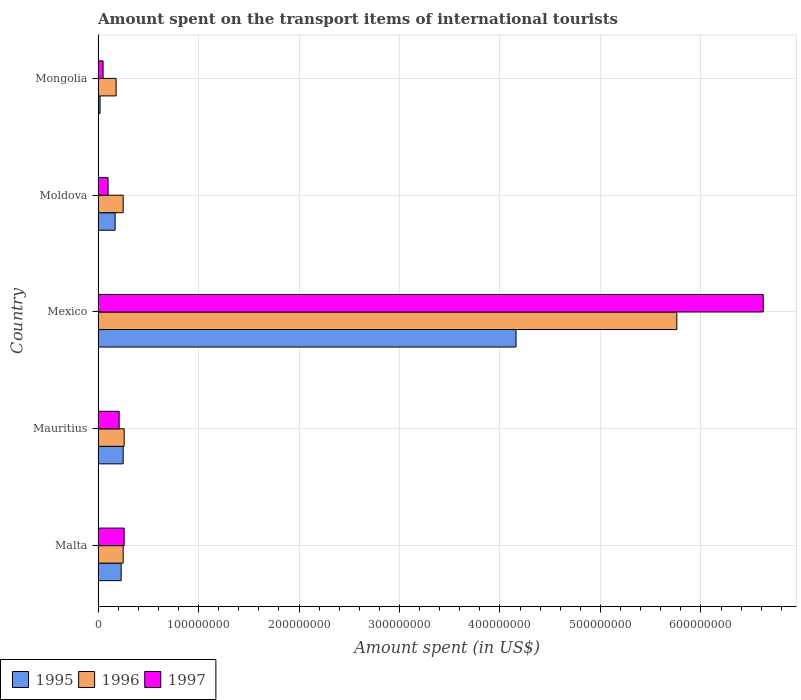Are the number of bars per tick equal to the number of legend labels?
Provide a succinct answer. Yes. How many bars are there on the 4th tick from the bottom?
Ensure brevity in your answer.  3. What is the label of the 5th group of bars from the top?
Ensure brevity in your answer.  Malta. In how many cases, is the number of bars for a given country not equal to the number of legend labels?
Give a very brief answer. 0. What is the amount spent on the transport items of international tourists in 1996 in Mexico?
Ensure brevity in your answer.  5.76e+08. Across all countries, what is the maximum amount spent on the transport items of international tourists in 1997?
Make the answer very short. 6.62e+08. Across all countries, what is the minimum amount spent on the transport items of international tourists in 1995?
Make the answer very short. 2.00e+06. In which country was the amount spent on the transport items of international tourists in 1997 maximum?
Give a very brief answer. Mexico. In which country was the amount spent on the transport items of international tourists in 1996 minimum?
Offer a terse response. Mongolia. What is the total amount spent on the transport items of international tourists in 1997 in the graph?
Your answer should be very brief. 7.24e+08. What is the difference between the amount spent on the transport items of international tourists in 1995 in Mauritius and that in Mongolia?
Your answer should be compact. 2.30e+07. What is the average amount spent on the transport items of international tourists in 1996 per country?
Keep it short and to the point. 1.34e+08. What is the difference between the amount spent on the transport items of international tourists in 1997 and amount spent on the transport items of international tourists in 1996 in Mongolia?
Keep it short and to the point. -1.30e+07. In how many countries, is the amount spent on the transport items of international tourists in 1996 greater than 300000000 US$?
Ensure brevity in your answer.  1. Is the amount spent on the transport items of international tourists in 1997 in Malta less than that in Mauritius?
Your answer should be very brief. No. Is the difference between the amount spent on the transport items of international tourists in 1997 in Moldova and Mongolia greater than the difference between the amount spent on the transport items of international tourists in 1996 in Moldova and Mongolia?
Your answer should be very brief. No. What is the difference between the highest and the second highest amount spent on the transport items of international tourists in 1995?
Your response must be concise. 3.91e+08. What is the difference between the highest and the lowest amount spent on the transport items of international tourists in 1995?
Provide a short and direct response. 4.14e+08. In how many countries, is the amount spent on the transport items of international tourists in 1997 greater than the average amount spent on the transport items of international tourists in 1997 taken over all countries?
Make the answer very short. 1. Is the sum of the amount spent on the transport items of international tourists in 1997 in Malta and Mongolia greater than the maximum amount spent on the transport items of international tourists in 1996 across all countries?
Provide a short and direct response. No. What does the 1st bar from the top in Malta represents?
Offer a very short reply. 1997. What does the 3rd bar from the bottom in Mauritius represents?
Provide a succinct answer. 1997. Does the graph contain grids?
Provide a succinct answer. Yes. Where does the legend appear in the graph?
Your response must be concise. Bottom left. How many legend labels are there?
Give a very brief answer. 3. How are the legend labels stacked?
Offer a very short reply. Horizontal. What is the title of the graph?
Your answer should be compact. Amount spent on the transport items of international tourists. What is the label or title of the X-axis?
Provide a succinct answer. Amount spent (in US$). What is the Amount spent (in US$) in 1995 in Malta?
Your answer should be very brief. 2.30e+07. What is the Amount spent (in US$) in 1996 in Malta?
Your answer should be compact. 2.50e+07. What is the Amount spent (in US$) of 1997 in Malta?
Provide a succinct answer. 2.60e+07. What is the Amount spent (in US$) of 1995 in Mauritius?
Offer a terse response. 2.50e+07. What is the Amount spent (in US$) in 1996 in Mauritius?
Keep it short and to the point. 2.60e+07. What is the Amount spent (in US$) in 1997 in Mauritius?
Provide a succinct answer. 2.10e+07. What is the Amount spent (in US$) in 1995 in Mexico?
Give a very brief answer. 4.16e+08. What is the Amount spent (in US$) of 1996 in Mexico?
Your answer should be very brief. 5.76e+08. What is the Amount spent (in US$) in 1997 in Mexico?
Keep it short and to the point. 6.62e+08. What is the Amount spent (in US$) of 1995 in Moldova?
Provide a short and direct response. 1.70e+07. What is the Amount spent (in US$) of 1996 in Moldova?
Your answer should be very brief. 2.50e+07. What is the Amount spent (in US$) of 1996 in Mongolia?
Offer a very short reply. 1.80e+07. What is the Amount spent (in US$) of 1997 in Mongolia?
Make the answer very short. 5.00e+06. Across all countries, what is the maximum Amount spent (in US$) of 1995?
Your answer should be very brief. 4.16e+08. Across all countries, what is the maximum Amount spent (in US$) in 1996?
Make the answer very short. 5.76e+08. Across all countries, what is the maximum Amount spent (in US$) in 1997?
Your answer should be compact. 6.62e+08. Across all countries, what is the minimum Amount spent (in US$) of 1995?
Your response must be concise. 2.00e+06. Across all countries, what is the minimum Amount spent (in US$) of 1996?
Ensure brevity in your answer.  1.80e+07. Across all countries, what is the minimum Amount spent (in US$) in 1997?
Make the answer very short. 5.00e+06. What is the total Amount spent (in US$) in 1995 in the graph?
Offer a very short reply. 4.83e+08. What is the total Amount spent (in US$) of 1996 in the graph?
Provide a short and direct response. 6.70e+08. What is the total Amount spent (in US$) in 1997 in the graph?
Offer a very short reply. 7.24e+08. What is the difference between the Amount spent (in US$) in 1996 in Malta and that in Mauritius?
Provide a short and direct response. -1.00e+06. What is the difference between the Amount spent (in US$) of 1997 in Malta and that in Mauritius?
Your response must be concise. 5.00e+06. What is the difference between the Amount spent (in US$) in 1995 in Malta and that in Mexico?
Make the answer very short. -3.93e+08. What is the difference between the Amount spent (in US$) of 1996 in Malta and that in Mexico?
Give a very brief answer. -5.51e+08. What is the difference between the Amount spent (in US$) in 1997 in Malta and that in Mexico?
Make the answer very short. -6.36e+08. What is the difference between the Amount spent (in US$) of 1997 in Malta and that in Moldova?
Offer a terse response. 1.60e+07. What is the difference between the Amount spent (in US$) of 1995 in Malta and that in Mongolia?
Make the answer very short. 2.10e+07. What is the difference between the Amount spent (in US$) of 1996 in Malta and that in Mongolia?
Offer a very short reply. 7.00e+06. What is the difference between the Amount spent (in US$) in 1997 in Malta and that in Mongolia?
Offer a terse response. 2.10e+07. What is the difference between the Amount spent (in US$) in 1995 in Mauritius and that in Mexico?
Keep it short and to the point. -3.91e+08. What is the difference between the Amount spent (in US$) of 1996 in Mauritius and that in Mexico?
Provide a short and direct response. -5.50e+08. What is the difference between the Amount spent (in US$) in 1997 in Mauritius and that in Mexico?
Offer a terse response. -6.41e+08. What is the difference between the Amount spent (in US$) of 1997 in Mauritius and that in Moldova?
Provide a succinct answer. 1.10e+07. What is the difference between the Amount spent (in US$) in 1995 in Mauritius and that in Mongolia?
Offer a very short reply. 2.30e+07. What is the difference between the Amount spent (in US$) in 1996 in Mauritius and that in Mongolia?
Keep it short and to the point. 8.00e+06. What is the difference between the Amount spent (in US$) of 1997 in Mauritius and that in Mongolia?
Your answer should be compact. 1.60e+07. What is the difference between the Amount spent (in US$) of 1995 in Mexico and that in Moldova?
Your answer should be compact. 3.99e+08. What is the difference between the Amount spent (in US$) of 1996 in Mexico and that in Moldova?
Provide a succinct answer. 5.51e+08. What is the difference between the Amount spent (in US$) of 1997 in Mexico and that in Moldova?
Your answer should be compact. 6.52e+08. What is the difference between the Amount spent (in US$) in 1995 in Mexico and that in Mongolia?
Keep it short and to the point. 4.14e+08. What is the difference between the Amount spent (in US$) of 1996 in Mexico and that in Mongolia?
Provide a succinct answer. 5.58e+08. What is the difference between the Amount spent (in US$) of 1997 in Mexico and that in Mongolia?
Give a very brief answer. 6.57e+08. What is the difference between the Amount spent (in US$) of 1995 in Moldova and that in Mongolia?
Offer a very short reply. 1.50e+07. What is the difference between the Amount spent (in US$) in 1995 in Malta and the Amount spent (in US$) in 1996 in Mauritius?
Your answer should be very brief. -3.00e+06. What is the difference between the Amount spent (in US$) of 1996 in Malta and the Amount spent (in US$) of 1997 in Mauritius?
Offer a very short reply. 4.00e+06. What is the difference between the Amount spent (in US$) in 1995 in Malta and the Amount spent (in US$) in 1996 in Mexico?
Your response must be concise. -5.53e+08. What is the difference between the Amount spent (in US$) in 1995 in Malta and the Amount spent (in US$) in 1997 in Mexico?
Give a very brief answer. -6.39e+08. What is the difference between the Amount spent (in US$) in 1996 in Malta and the Amount spent (in US$) in 1997 in Mexico?
Your answer should be very brief. -6.37e+08. What is the difference between the Amount spent (in US$) in 1995 in Malta and the Amount spent (in US$) in 1996 in Moldova?
Your response must be concise. -2.00e+06. What is the difference between the Amount spent (in US$) of 1995 in Malta and the Amount spent (in US$) of 1997 in Moldova?
Ensure brevity in your answer.  1.30e+07. What is the difference between the Amount spent (in US$) in 1996 in Malta and the Amount spent (in US$) in 1997 in Moldova?
Provide a short and direct response. 1.50e+07. What is the difference between the Amount spent (in US$) of 1995 in Malta and the Amount spent (in US$) of 1996 in Mongolia?
Keep it short and to the point. 5.00e+06. What is the difference between the Amount spent (in US$) of 1995 in Malta and the Amount spent (in US$) of 1997 in Mongolia?
Make the answer very short. 1.80e+07. What is the difference between the Amount spent (in US$) of 1995 in Mauritius and the Amount spent (in US$) of 1996 in Mexico?
Your answer should be compact. -5.51e+08. What is the difference between the Amount spent (in US$) in 1995 in Mauritius and the Amount spent (in US$) in 1997 in Mexico?
Give a very brief answer. -6.37e+08. What is the difference between the Amount spent (in US$) of 1996 in Mauritius and the Amount spent (in US$) of 1997 in Mexico?
Provide a short and direct response. -6.36e+08. What is the difference between the Amount spent (in US$) of 1995 in Mauritius and the Amount spent (in US$) of 1997 in Moldova?
Offer a very short reply. 1.50e+07. What is the difference between the Amount spent (in US$) of 1996 in Mauritius and the Amount spent (in US$) of 1997 in Moldova?
Offer a terse response. 1.60e+07. What is the difference between the Amount spent (in US$) in 1995 in Mauritius and the Amount spent (in US$) in 1996 in Mongolia?
Ensure brevity in your answer.  7.00e+06. What is the difference between the Amount spent (in US$) of 1995 in Mauritius and the Amount spent (in US$) of 1997 in Mongolia?
Your response must be concise. 2.00e+07. What is the difference between the Amount spent (in US$) of 1996 in Mauritius and the Amount spent (in US$) of 1997 in Mongolia?
Provide a short and direct response. 2.10e+07. What is the difference between the Amount spent (in US$) in 1995 in Mexico and the Amount spent (in US$) in 1996 in Moldova?
Ensure brevity in your answer.  3.91e+08. What is the difference between the Amount spent (in US$) of 1995 in Mexico and the Amount spent (in US$) of 1997 in Moldova?
Offer a very short reply. 4.06e+08. What is the difference between the Amount spent (in US$) in 1996 in Mexico and the Amount spent (in US$) in 1997 in Moldova?
Keep it short and to the point. 5.66e+08. What is the difference between the Amount spent (in US$) in 1995 in Mexico and the Amount spent (in US$) in 1996 in Mongolia?
Offer a terse response. 3.98e+08. What is the difference between the Amount spent (in US$) in 1995 in Mexico and the Amount spent (in US$) in 1997 in Mongolia?
Provide a succinct answer. 4.11e+08. What is the difference between the Amount spent (in US$) of 1996 in Mexico and the Amount spent (in US$) of 1997 in Mongolia?
Your answer should be very brief. 5.71e+08. What is the difference between the Amount spent (in US$) of 1995 in Moldova and the Amount spent (in US$) of 1996 in Mongolia?
Keep it short and to the point. -1.00e+06. What is the difference between the Amount spent (in US$) of 1995 in Moldova and the Amount spent (in US$) of 1997 in Mongolia?
Your answer should be very brief. 1.20e+07. What is the average Amount spent (in US$) in 1995 per country?
Keep it short and to the point. 9.66e+07. What is the average Amount spent (in US$) of 1996 per country?
Offer a very short reply. 1.34e+08. What is the average Amount spent (in US$) of 1997 per country?
Offer a very short reply. 1.45e+08. What is the difference between the Amount spent (in US$) of 1995 and Amount spent (in US$) of 1997 in Malta?
Offer a terse response. -3.00e+06. What is the difference between the Amount spent (in US$) of 1995 and Amount spent (in US$) of 1996 in Mauritius?
Make the answer very short. -1.00e+06. What is the difference between the Amount spent (in US$) of 1995 and Amount spent (in US$) of 1997 in Mauritius?
Your answer should be compact. 4.00e+06. What is the difference between the Amount spent (in US$) in 1996 and Amount spent (in US$) in 1997 in Mauritius?
Offer a very short reply. 5.00e+06. What is the difference between the Amount spent (in US$) of 1995 and Amount spent (in US$) of 1996 in Mexico?
Offer a terse response. -1.60e+08. What is the difference between the Amount spent (in US$) in 1995 and Amount spent (in US$) in 1997 in Mexico?
Your answer should be very brief. -2.46e+08. What is the difference between the Amount spent (in US$) of 1996 and Amount spent (in US$) of 1997 in Mexico?
Offer a very short reply. -8.60e+07. What is the difference between the Amount spent (in US$) of 1995 and Amount spent (in US$) of 1996 in Moldova?
Offer a terse response. -8.00e+06. What is the difference between the Amount spent (in US$) in 1996 and Amount spent (in US$) in 1997 in Moldova?
Provide a short and direct response. 1.50e+07. What is the difference between the Amount spent (in US$) in 1995 and Amount spent (in US$) in 1996 in Mongolia?
Provide a succinct answer. -1.60e+07. What is the difference between the Amount spent (in US$) in 1995 and Amount spent (in US$) in 1997 in Mongolia?
Make the answer very short. -3.00e+06. What is the difference between the Amount spent (in US$) in 1996 and Amount spent (in US$) in 1997 in Mongolia?
Your answer should be compact. 1.30e+07. What is the ratio of the Amount spent (in US$) of 1996 in Malta to that in Mauritius?
Make the answer very short. 0.96. What is the ratio of the Amount spent (in US$) in 1997 in Malta to that in Mauritius?
Offer a very short reply. 1.24. What is the ratio of the Amount spent (in US$) in 1995 in Malta to that in Mexico?
Offer a very short reply. 0.06. What is the ratio of the Amount spent (in US$) of 1996 in Malta to that in Mexico?
Offer a terse response. 0.04. What is the ratio of the Amount spent (in US$) in 1997 in Malta to that in Mexico?
Ensure brevity in your answer.  0.04. What is the ratio of the Amount spent (in US$) in 1995 in Malta to that in Moldova?
Keep it short and to the point. 1.35. What is the ratio of the Amount spent (in US$) of 1997 in Malta to that in Moldova?
Keep it short and to the point. 2.6. What is the ratio of the Amount spent (in US$) of 1996 in Malta to that in Mongolia?
Provide a short and direct response. 1.39. What is the ratio of the Amount spent (in US$) of 1995 in Mauritius to that in Mexico?
Your response must be concise. 0.06. What is the ratio of the Amount spent (in US$) in 1996 in Mauritius to that in Mexico?
Your response must be concise. 0.05. What is the ratio of the Amount spent (in US$) of 1997 in Mauritius to that in Mexico?
Offer a very short reply. 0.03. What is the ratio of the Amount spent (in US$) in 1995 in Mauritius to that in Moldova?
Keep it short and to the point. 1.47. What is the ratio of the Amount spent (in US$) in 1997 in Mauritius to that in Moldova?
Your response must be concise. 2.1. What is the ratio of the Amount spent (in US$) of 1996 in Mauritius to that in Mongolia?
Your answer should be compact. 1.44. What is the ratio of the Amount spent (in US$) of 1997 in Mauritius to that in Mongolia?
Your response must be concise. 4.2. What is the ratio of the Amount spent (in US$) of 1995 in Mexico to that in Moldova?
Your answer should be compact. 24.47. What is the ratio of the Amount spent (in US$) of 1996 in Mexico to that in Moldova?
Your response must be concise. 23.04. What is the ratio of the Amount spent (in US$) of 1997 in Mexico to that in Moldova?
Your answer should be very brief. 66.2. What is the ratio of the Amount spent (in US$) in 1995 in Mexico to that in Mongolia?
Make the answer very short. 208. What is the ratio of the Amount spent (in US$) in 1997 in Mexico to that in Mongolia?
Ensure brevity in your answer.  132.4. What is the ratio of the Amount spent (in US$) of 1995 in Moldova to that in Mongolia?
Your response must be concise. 8.5. What is the ratio of the Amount spent (in US$) of 1996 in Moldova to that in Mongolia?
Provide a short and direct response. 1.39. What is the ratio of the Amount spent (in US$) in 1997 in Moldova to that in Mongolia?
Provide a succinct answer. 2. What is the difference between the highest and the second highest Amount spent (in US$) in 1995?
Ensure brevity in your answer.  3.91e+08. What is the difference between the highest and the second highest Amount spent (in US$) in 1996?
Give a very brief answer. 5.50e+08. What is the difference between the highest and the second highest Amount spent (in US$) of 1997?
Your response must be concise. 6.36e+08. What is the difference between the highest and the lowest Amount spent (in US$) of 1995?
Your answer should be compact. 4.14e+08. What is the difference between the highest and the lowest Amount spent (in US$) of 1996?
Give a very brief answer. 5.58e+08. What is the difference between the highest and the lowest Amount spent (in US$) of 1997?
Your answer should be very brief. 6.57e+08. 